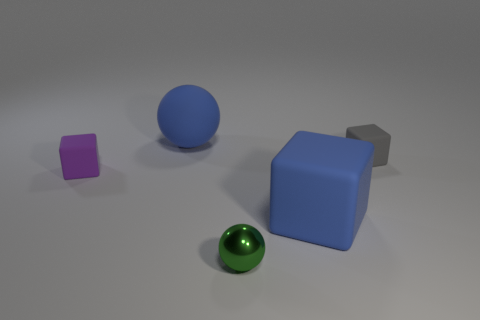What shape is the matte object that is the same color as the matte ball?
Offer a very short reply. Cube. How many other things are there of the same color as the shiny ball?
Offer a very short reply. 0. Are there more blue rubber cubes that are to the right of the gray rubber object than small brown shiny objects?
Offer a terse response. No. Is the material of the big blue ball the same as the large blue block?
Your answer should be very brief. Yes. How many things are either tiny matte cubes on the left side of the tiny green ball or purple metallic cylinders?
Provide a short and direct response. 1. What number of other things are the same size as the green thing?
Ensure brevity in your answer.  2. Is the number of purple rubber things to the right of the gray cube the same as the number of large blue matte cubes on the left side of the blue matte sphere?
Keep it short and to the point. Yes. There is another small matte object that is the same shape as the purple thing; what color is it?
Offer a terse response. Gray. Are there any other things that are the same shape as the small purple rubber thing?
Ensure brevity in your answer.  Yes. Do the ball behind the purple matte block and the large cube have the same color?
Offer a terse response. Yes. 